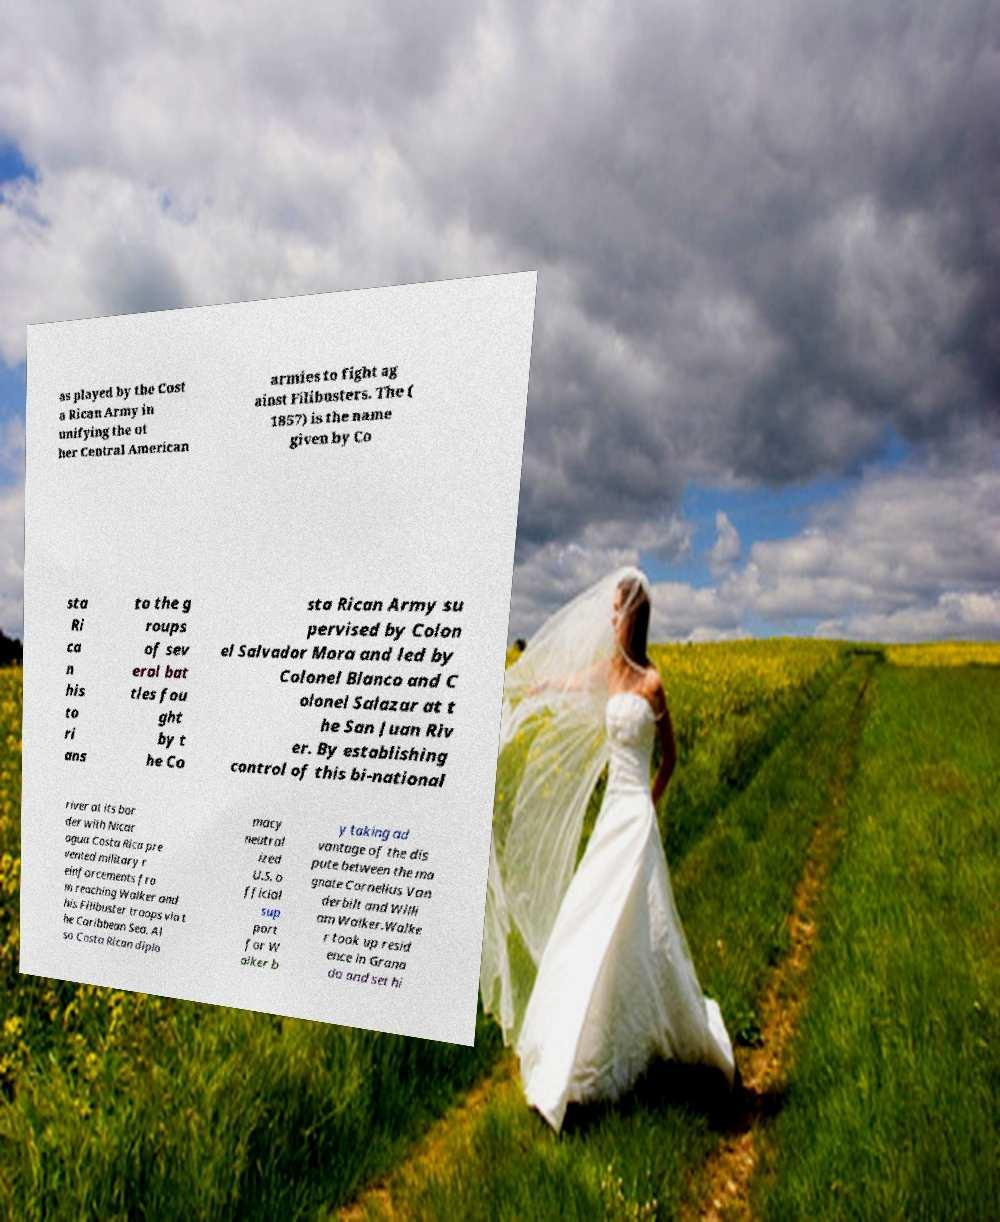Could you assist in decoding the text presented in this image and type it out clearly? as played by the Cost a Rican Army in unifying the ot her Central American armies to fight ag ainst Filibusters. The ( 1857) is the name given by Co sta Ri ca n his to ri ans to the g roups of sev eral bat tles fou ght by t he Co sta Rican Army su pervised by Colon el Salvador Mora and led by Colonel Blanco and C olonel Salazar at t he San Juan Riv er. By establishing control of this bi-national river at its bor der with Nicar agua Costa Rica pre vented military r einforcements fro m reaching Walker and his Filibuster troops via t he Caribbean Sea. Al so Costa Rican diplo macy neutral ized U.S. o fficial sup port for W alker b y taking ad vantage of the dis pute between the ma gnate Cornelius Van derbilt and Willi am Walker.Walke r took up resid ence in Grana da and set hi 